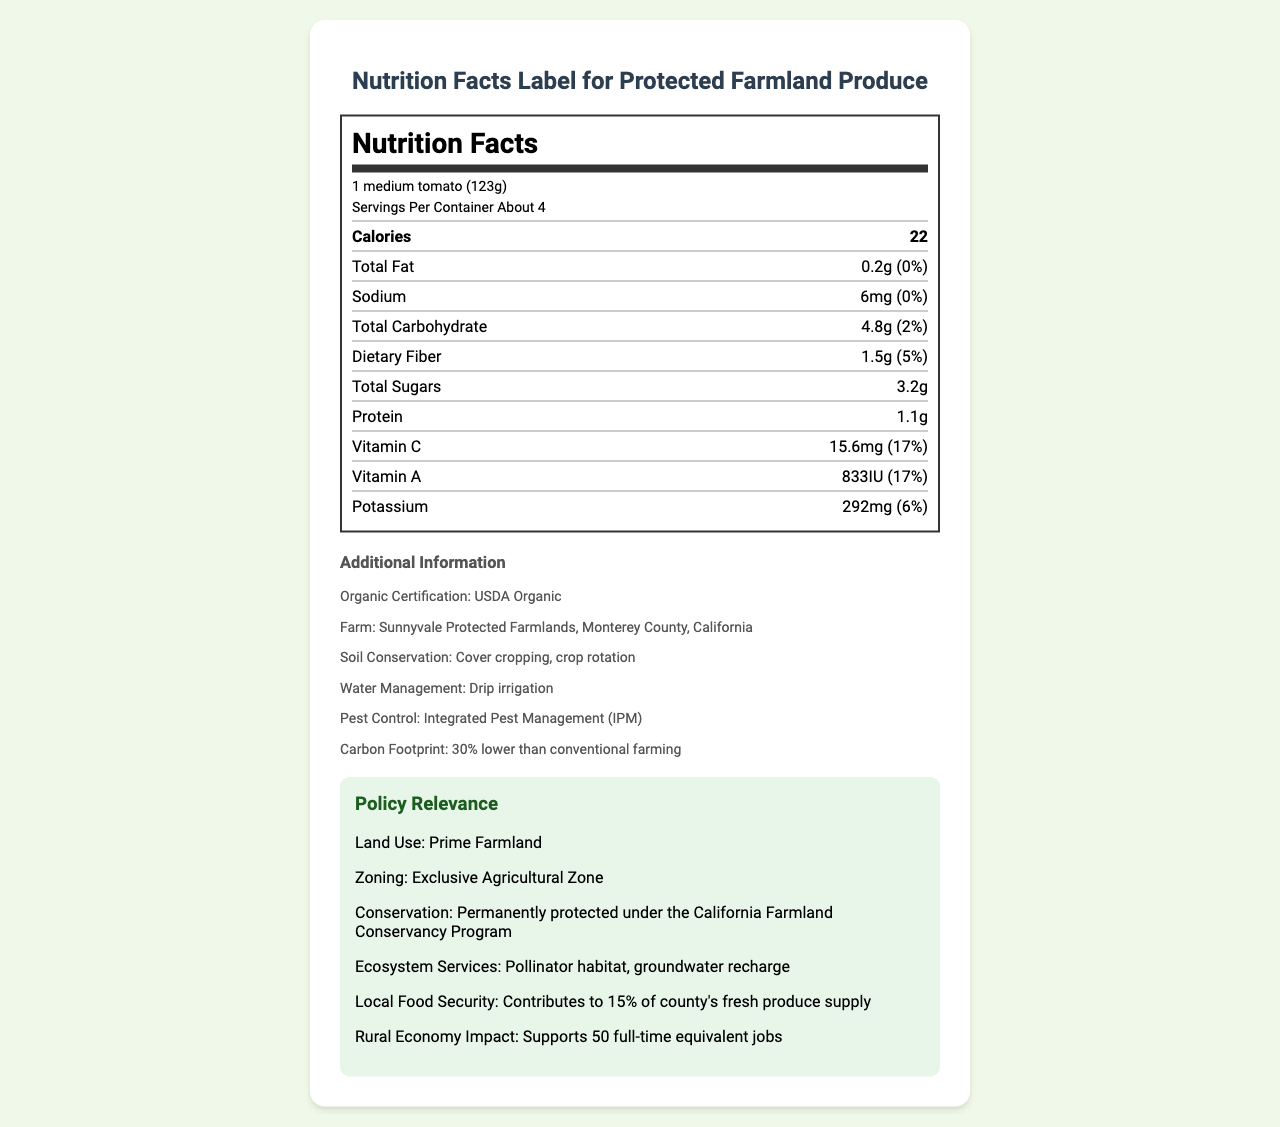what is the serving size for Organic Heirloom Tomatoes? The serving size is stated directly in the document as "1 medium tomato (123g)."
Answer: 1 medium tomato (123g) how many calories are in one serving? The document specifies that one serving contains 22 calories.
Answer: 22 what is the total fat amount in one serving? The total fat amount per serving is listed as 0.2g.
Answer: 0.2g how much sodium is in one serving? The sodium content per serving is provided as 6mg.
Answer: 6mg what percentage of the daily value for Vitamin A does one serving provide? It is mentioned that Vitamin A contributes 17% of the daily value per serving.
Answer: 17% which organization certifies the produce as organic? A. USDA B. FDA C. EPA D. None of the above The document states that the produce has a USDA Organic certification.
Answer: A. USDA how much dietary fiber is in a single serving? The dietary fiber content per serving is given as 1.5g.
Answer: 1.5g what are the soil conservation practices used by Sunnyvale Protected Farmlands? The document lists "Cover cropping, crop rotation" as the soil conservation practices.
Answer: Cover cropping, crop rotation what is the effect on the carbon footprint for this farming method? The carbon footprint is stated to be 30% lower than conventional farming.
Answer: 30% lower than conventional farming which of the following best describes the land use designation? A. Urban Land B. Suburban Land C. Prime Farmland D. Wetlands The land use designation is described as "Prime Farmland."
Answer: C. Prime Farmland does the farm use drip irrigation for water management? The document specifies that water management includes "Drip irrigation."
Answer: Yes explain the impact on the rural economy according to the document. The document states that the impact on the rural economy includes supporting 50 full-time equivalent jobs.
Answer: Supports 50 full-time equivalent jobs what's the local food security contribution of this farm? The document mentions that it contributes to 15% of the county's fresh produce supply.
Answer: Contributes to 15% of county's fresh produce supply what information cannot be determined from the document? The document does not provide any information regarding the price of the tomatoes.
Answer: The specific price of Organic Heirloom Tomatoes summarize the main idea of the document. The summary captures the key elements including nutritional information, organic certification, farming and conservation practices, and the broader policy impacts of the farm.
Answer: The document is a nutrition facts label for Organic Heirloom Tomatoes grown at Sunnyvale Protected Farmlands in Monterey County, California, detailing the nutritional content per serving, additional organic farming practices, and policy relevance pertaining to land use, conservation, ecosystem services, and economic impacts. what percentage of the daily value for potassium does one serving provide? The daily value for potassium per serving is indicated as 6%.
Answer: 6% 